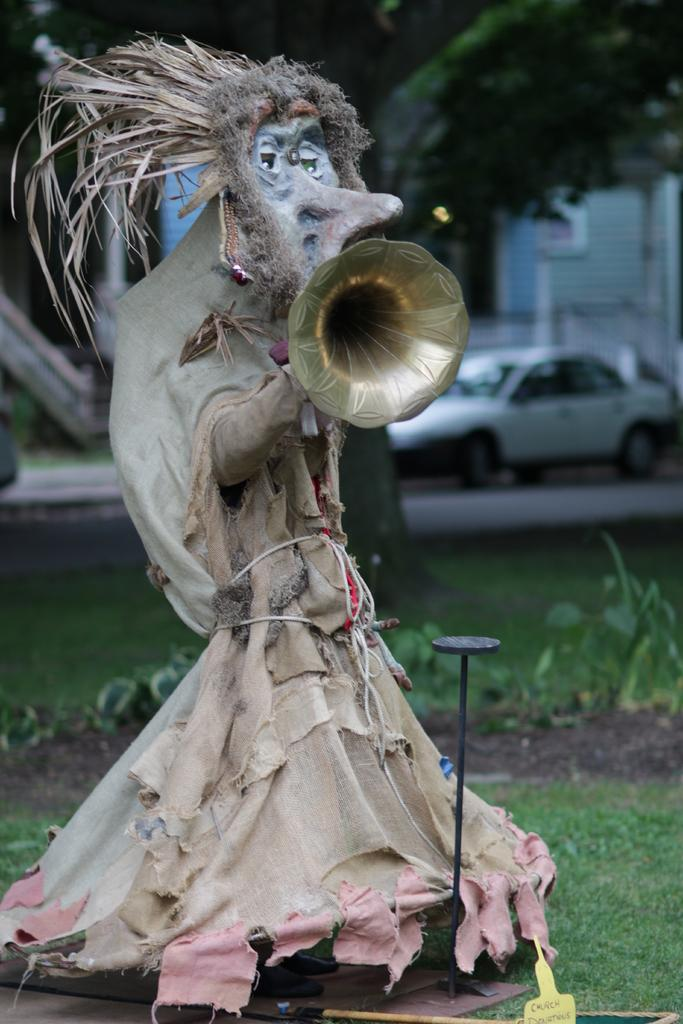What is the main subject of the image? There is a statue of a creature in the image. What is the creature holding in the image? The creature is holding a trumpet. What is on the head of the creature? There is grass on the head of the creature. What type of vegetation is visible in the image? There is grass and trees visible in the image. What else can be seen in the image besides the statue and vegetation? There are vehicles on the road in the image. What type of box is being carried by the stranger in the image? There is no stranger or box present in the image; it features a statue of a creature holding a trumpet. What is the texture of the creature's skin in the image? The texture of the creature's skin cannot be determined from the image, as it is a statue and not a living creature. 